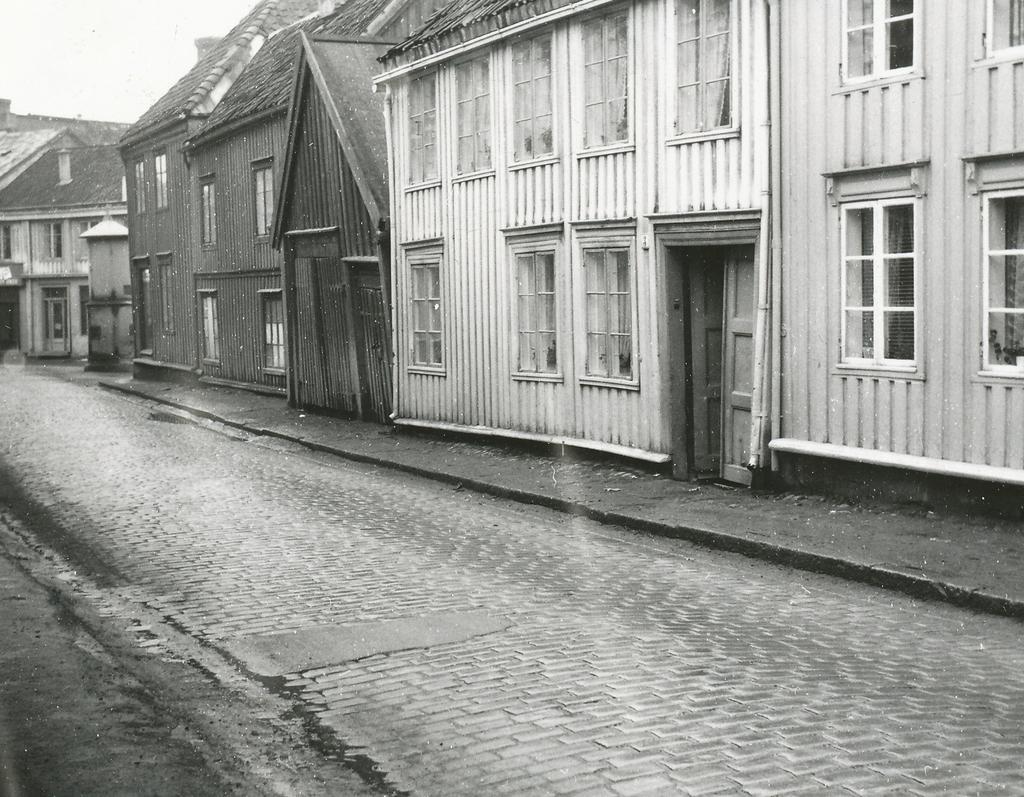In one or two sentences, can you explain what this image depicts? This is a black and white image. In this image we can see a group of houses with roof, windows and the doors. We can also see the pathway and the sky. 